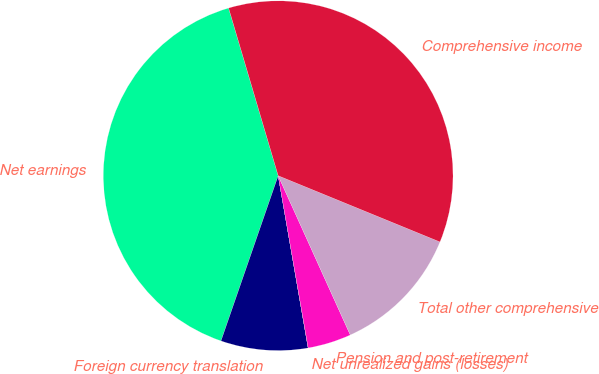Convert chart. <chart><loc_0><loc_0><loc_500><loc_500><pie_chart><fcel>Net earnings<fcel>Foreign currency translation<fcel>Net unrealized gains (losses)<fcel>Pension and post-retirement<fcel>Total other comprehensive<fcel>Comprehensive income<nl><fcel>40.12%<fcel>8.04%<fcel>0.01%<fcel>4.02%<fcel>12.05%<fcel>35.76%<nl></chart> 